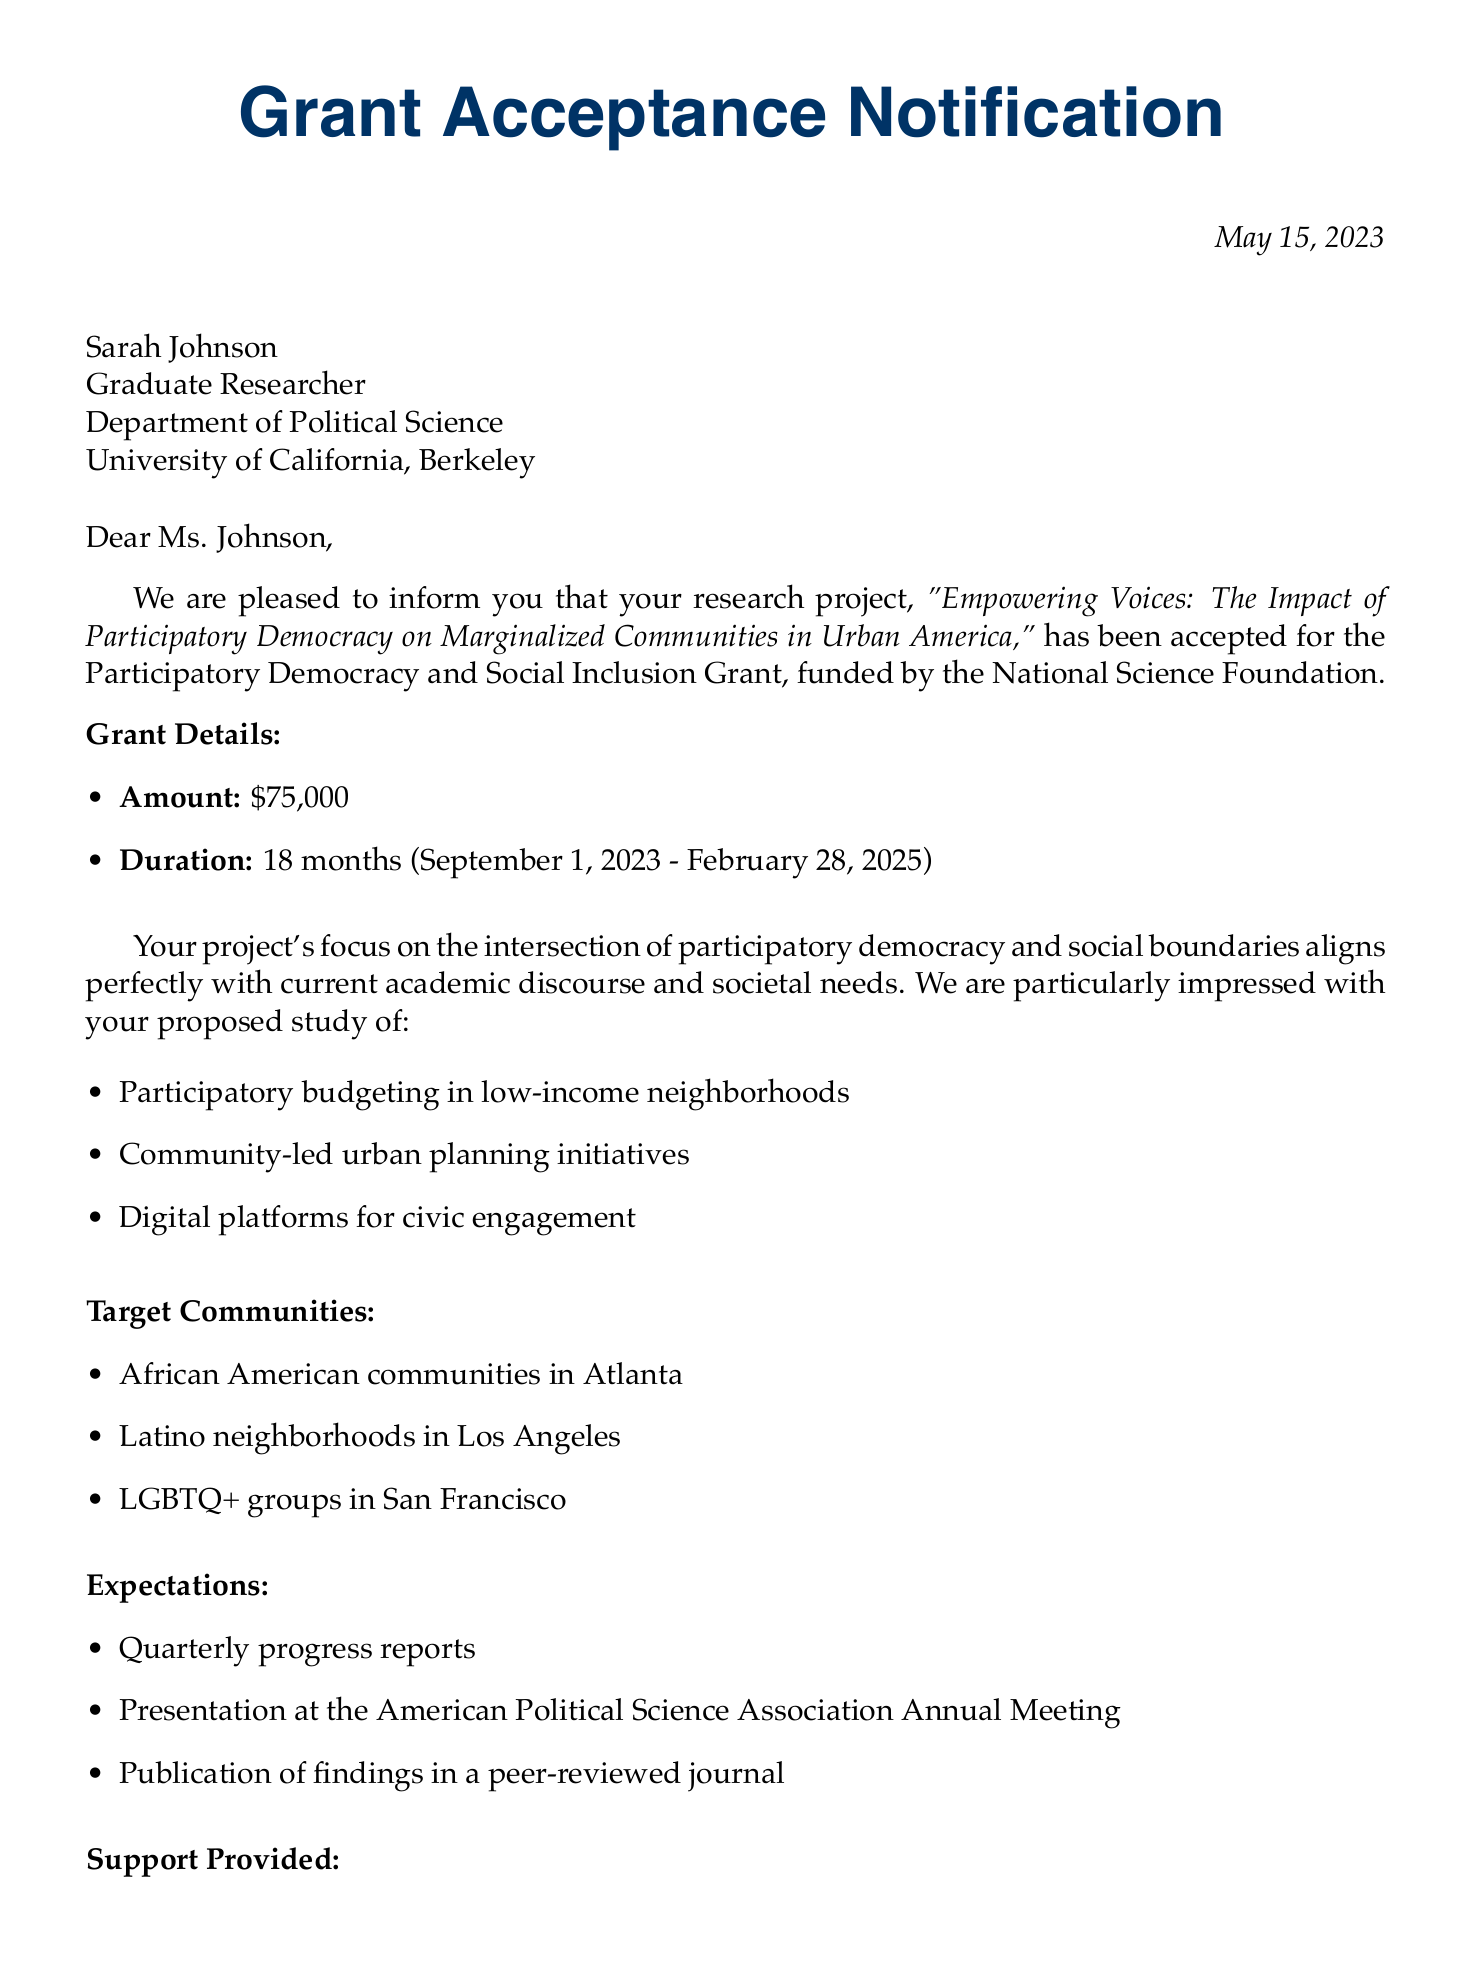What is the name of the research project? The name of the research project is stated in the letter and is "Empowering Voices: The Impact of Participatory Democracy on Marginalized Communities in Urban America."
Answer: Empowering Voices: The Impact of Participatory Democracy on Marginalized Communities in Urban America Who is the recipient of the grant? The recipient of the grant is mentioned at the beginning of the letter as Sarah Johnson.
Answer: Sarah Johnson What is the amount of funding provided? The letter specifies the funding amount for the grant, which is $75,000.
Answer: $75,000 What are the target communities of the research project? The letter lists specific communities as target groups for the research, including African American communities in Atlanta, Latino neighborhoods in Los Angeles, and LGBTQ+ groups in San Francisco.
Answer: African American communities in Atlanta, Latino neighborhoods in Los Angeles, LGBTQ+ groups in San Francisco When is the project expected to start? The letter provides the project start date, which is September 1, 2023.
Answer: September 1, 2023 What is one expectation from the research project? The letter highlights several expectations, and one of them is requiring "Quarterly progress reports."
Answer: Quarterly progress reports What support will be provided to the researcher? The letter outlines various support options, and one of them is "Access to NSF research databases."
Answer: Access to NSF research databases What is one of the next steps listed in the letter? The letter details the next steps, including signing and returning the grant acceptance form as one required action.
Answer: Sign and return the grant acceptance form 